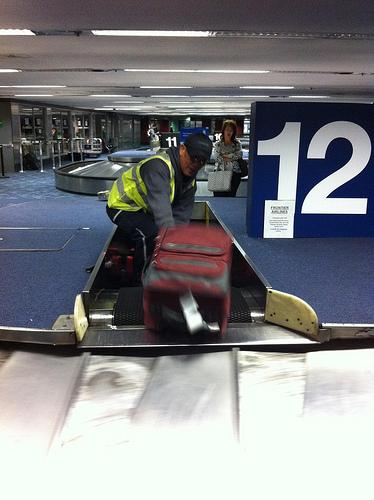Provide a short yet detailed description of the key objects in the image. A standing woman with arms crossed, a man wearing a blue cap and a gray-yellow striped safety vest, and a red and black striped suitcase on a silver luggage carousel over airport's blue patterned carpet. Identify the main actions happening in the image in a concise manner. Woman stands with arms crossed, man wears blue cap and yellow vest, red suitcase on conveyor belt, blue carpet on airport floor. Give a description of the image's contents from the perspective of a robot. Image contains: woman-human (standing, arms crossed), man-human (blue cap, yellow safety vest), suitcase-object (red, conveyer belt), floor-pattern (blue carpet, airport). Provide a brief, informal description of the main objects in the image. There's a woman with arms crossed, a guy in a yellow vest and blue cap, a red suitcase on a conveyor belt, and a blue carpet at the airport. Describe the main elements of the image, with a focus on the colors visible. A woman with a white purse, a man wearing a yellow safety vest and blue cap, a red suitcase with black stripes on a silver conveyer belt, and the blue carpeted airport floor. Use a journalistic style to briefly summarize the main events taking place in the image. Amidst the hustle of the busy airport, a woman stands firm with arms crossed, as a worker in a yellow safety vest and blue cap assist in handling a red suitcase on the luggage carousel, over the carpeted blue floor. Summarize the main elements of the image in a single sentence. At the airport, a woman in arms-folded pose, a man in a yellow safety vest, and a red suitcase on a silver conveyor belt over blue carpet dominate the scene. Write a brief, poetic description of the scene in the image. In a busy airport scene, a woman stands defiant, amidst a sea of blue carpet, man in yellow vest strides, and luggage takes its journey on a conveyor belt. Imagine this image is part of a comic strip; write a one-line caption describing the scene. "Airport hustle: a stand-off between a defiant passenger, an attentive worker, and a trusty suitcase." Write a short and humorous description of the scene occurring in the image. Armed with crossed arms, one defiant woman takes on both a fashionable man in a blue cap and a rebellious red suitcase in a great airport showdown – all atop a sea of luxurious blue carpet. 